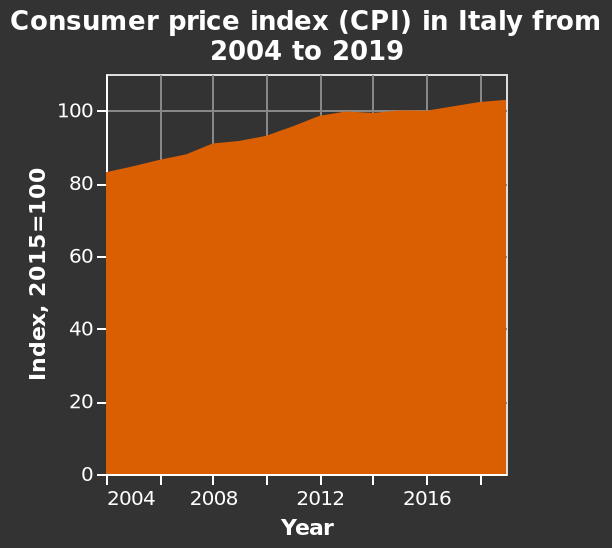<image>
Was there any year below 80?  No, there was no year mentioned that was below 80. From which year onwards were the values above 100?  From the year 2015 onwards, the values mentioned were above 100. What was the lowest year mentioned in the figure?  The lowest year mentioned in the figure is 2014. What was the highest year mentioned in the figure?  The highest year mentioned in the figure is 2019. Can you give an example of a year that had a value above 100? Yes, 2019 was an example of a year that had a value above 100. 